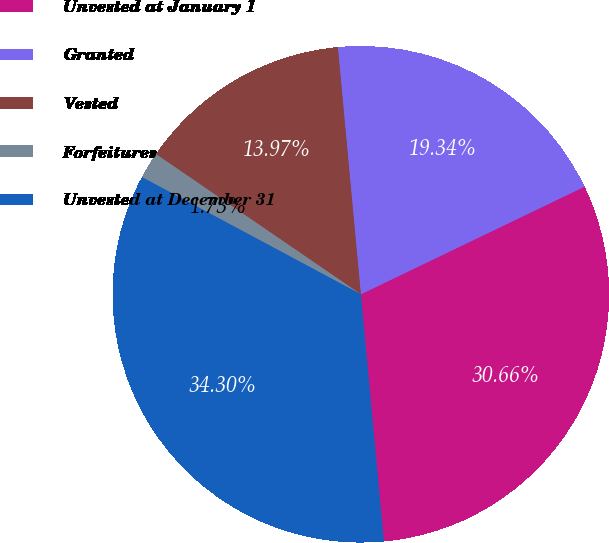<chart> <loc_0><loc_0><loc_500><loc_500><pie_chart><fcel>Unvested at January 1<fcel>Granted<fcel>Vested<fcel>Forfeitures<fcel>Unvested at December 31<nl><fcel>30.66%<fcel>19.34%<fcel>13.97%<fcel>1.73%<fcel>34.3%<nl></chart> 